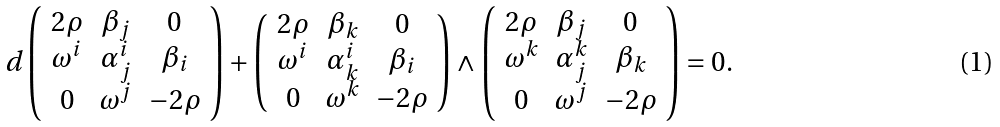<formula> <loc_0><loc_0><loc_500><loc_500>d \left ( \begin{array} { c c c } 2 \rho & \beta _ { j } & 0 \\ \omega ^ { i } & \alpha ^ { i } _ { j } & \beta _ { i } \\ 0 & \omega ^ { j } & - 2 \rho \end{array} \right ) + \left ( \begin{array} { c c c } 2 \rho & \beta _ { k } & 0 \\ \omega ^ { i } & \alpha ^ { i } _ { k } & \beta _ { i } \\ 0 & \omega ^ { k } & - 2 \rho \end{array} \right ) \wedge \left ( \begin{array} { c c c } 2 \rho & \beta _ { j } & 0 \\ \omega ^ { k } & \alpha ^ { k } _ { j } & \beta _ { k } \\ 0 & \omega ^ { j } & - 2 \rho \end{array} \right ) = 0 .</formula> 